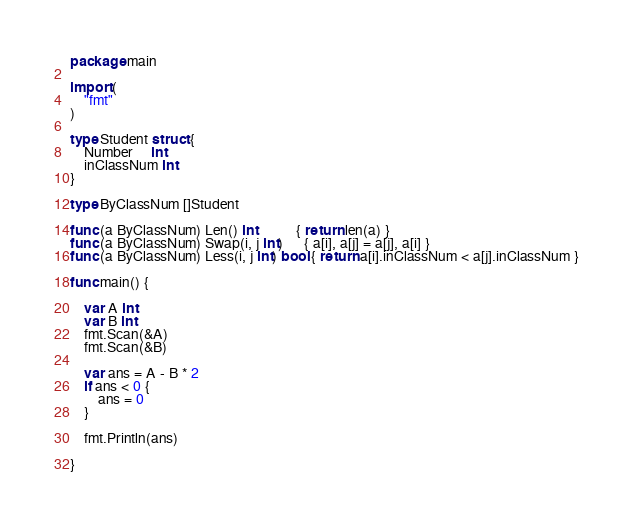Convert code to text. <code><loc_0><loc_0><loc_500><loc_500><_Go_>package main

import (
	"fmt"
)

type Student struct {
	Number     int
	inClassNum int
}

type ByClassNum []Student

func (a ByClassNum) Len() int           { return len(a) }
func (a ByClassNum) Swap(i, j int)      { a[i], a[j] = a[j], a[i] }
func (a ByClassNum) Less(i, j int) bool { return a[i].inClassNum < a[j].inClassNum }

func main() {

	var A int
	var B int
	fmt.Scan(&A)
	fmt.Scan(&B)

	var ans = A - B * 2
	if ans < 0 {
		ans = 0
	}

	fmt.Println(ans)

}</code> 